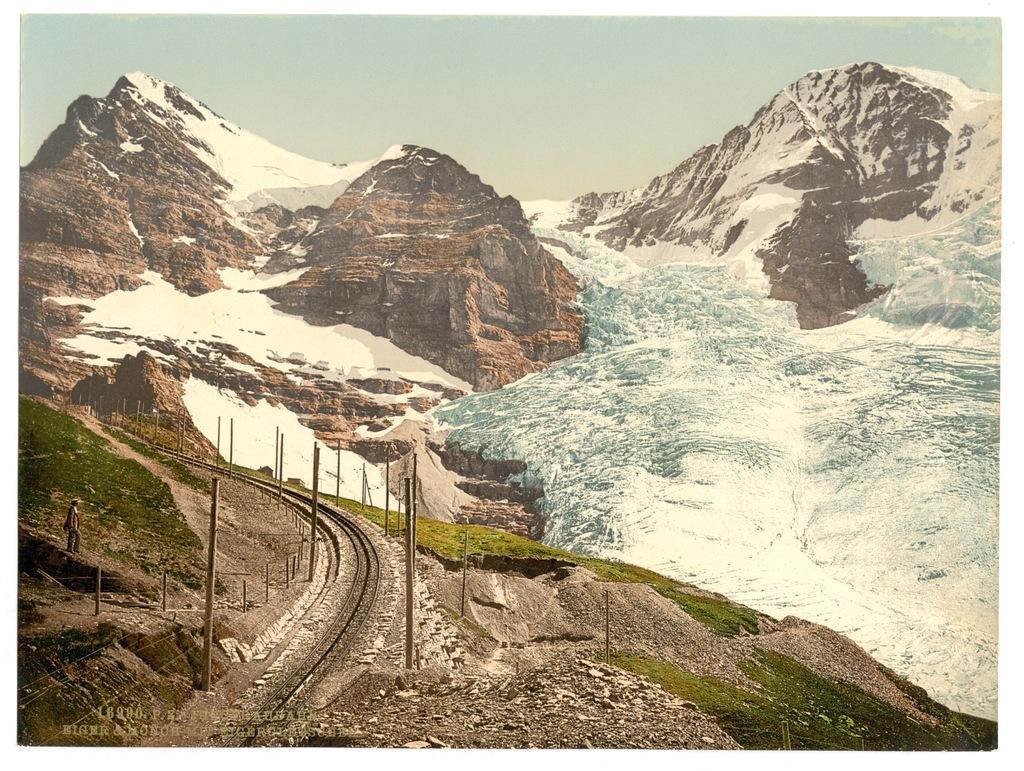Please provide a concise description of this image. In this picture I can see the snow mountains. On the left there is a man who is standing near to the grass. In the bottom left I can see the railway tracks, poles and some stones. At the top I can see the sky. 